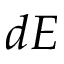<formula> <loc_0><loc_0><loc_500><loc_500>d E</formula> 